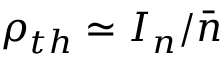<formula> <loc_0><loc_0><loc_500><loc_500>\rho _ { t h } \simeq I _ { n } / { \bar { n } }</formula> 